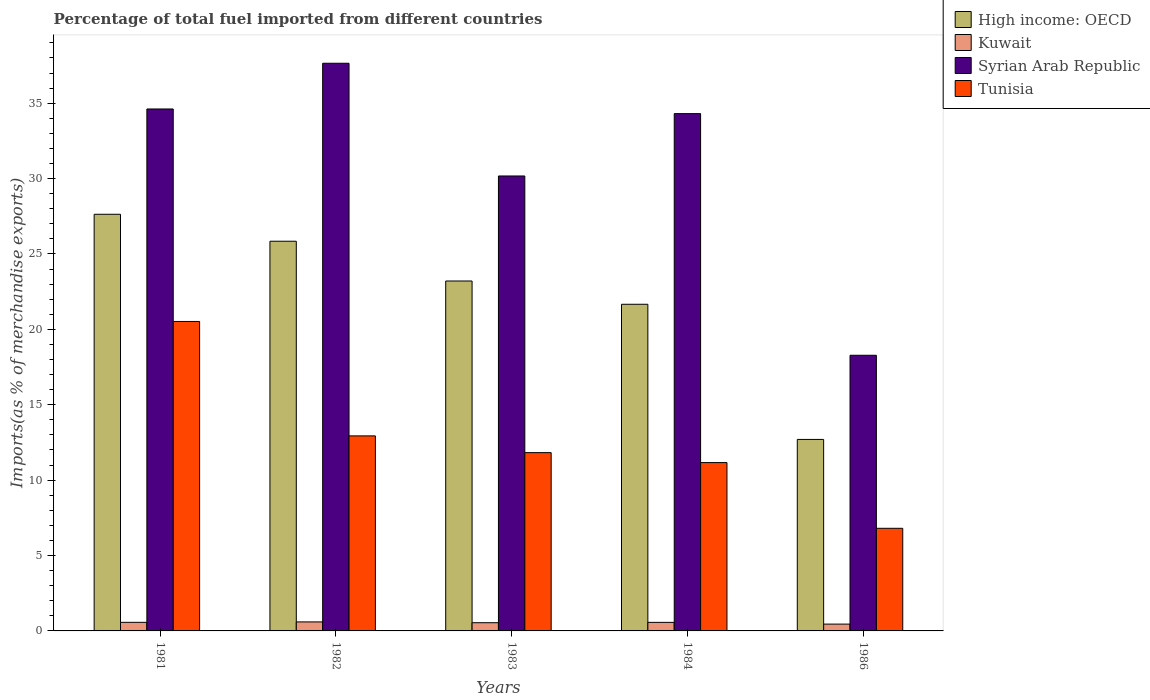How many groups of bars are there?
Make the answer very short. 5. Are the number of bars per tick equal to the number of legend labels?
Keep it short and to the point. Yes. What is the label of the 3rd group of bars from the left?
Make the answer very short. 1983. In how many cases, is the number of bars for a given year not equal to the number of legend labels?
Provide a succinct answer. 0. What is the percentage of imports to different countries in Tunisia in 1982?
Provide a short and direct response. 12.94. Across all years, what is the maximum percentage of imports to different countries in High income: OECD?
Provide a succinct answer. 27.63. Across all years, what is the minimum percentage of imports to different countries in High income: OECD?
Ensure brevity in your answer.  12.7. In which year was the percentage of imports to different countries in Syrian Arab Republic maximum?
Your response must be concise. 1982. What is the total percentage of imports to different countries in Syrian Arab Republic in the graph?
Offer a terse response. 155.03. What is the difference between the percentage of imports to different countries in High income: OECD in 1981 and that in 1983?
Your answer should be very brief. 4.42. What is the difference between the percentage of imports to different countries in High income: OECD in 1981 and the percentage of imports to different countries in Kuwait in 1983?
Your answer should be compact. 27.09. What is the average percentage of imports to different countries in Tunisia per year?
Provide a succinct answer. 12.65. In the year 1982, what is the difference between the percentage of imports to different countries in Syrian Arab Republic and percentage of imports to different countries in High income: OECD?
Your answer should be compact. 11.8. What is the ratio of the percentage of imports to different countries in Syrian Arab Republic in 1981 to that in 1982?
Offer a terse response. 0.92. Is the difference between the percentage of imports to different countries in Syrian Arab Republic in 1981 and 1983 greater than the difference between the percentage of imports to different countries in High income: OECD in 1981 and 1983?
Provide a short and direct response. Yes. What is the difference between the highest and the second highest percentage of imports to different countries in Kuwait?
Your answer should be very brief. 0.03. What is the difference between the highest and the lowest percentage of imports to different countries in High income: OECD?
Your answer should be compact. 14.93. Is it the case that in every year, the sum of the percentage of imports to different countries in High income: OECD and percentage of imports to different countries in Syrian Arab Republic is greater than the sum of percentage of imports to different countries in Kuwait and percentage of imports to different countries in Tunisia?
Your response must be concise. No. What does the 2nd bar from the left in 1984 represents?
Offer a very short reply. Kuwait. What does the 1st bar from the right in 1981 represents?
Give a very brief answer. Tunisia. Is it the case that in every year, the sum of the percentage of imports to different countries in High income: OECD and percentage of imports to different countries in Syrian Arab Republic is greater than the percentage of imports to different countries in Tunisia?
Your answer should be compact. Yes. How many bars are there?
Your answer should be very brief. 20. Does the graph contain grids?
Provide a short and direct response. No. What is the title of the graph?
Your response must be concise. Percentage of total fuel imported from different countries. Does "Burkina Faso" appear as one of the legend labels in the graph?
Your answer should be compact. No. What is the label or title of the X-axis?
Give a very brief answer. Years. What is the label or title of the Y-axis?
Ensure brevity in your answer.  Imports(as % of merchandise exports). What is the Imports(as % of merchandise exports) in High income: OECD in 1981?
Your response must be concise. 27.63. What is the Imports(as % of merchandise exports) of Kuwait in 1981?
Your response must be concise. 0.57. What is the Imports(as % of merchandise exports) in Syrian Arab Republic in 1981?
Give a very brief answer. 34.62. What is the Imports(as % of merchandise exports) of Tunisia in 1981?
Keep it short and to the point. 20.52. What is the Imports(as % of merchandise exports) of High income: OECD in 1982?
Your answer should be very brief. 25.85. What is the Imports(as % of merchandise exports) of Kuwait in 1982?
Your answer should be compact. 0.6. What is the Imports(as % of merchandise exports) in Syrian Arab Republic in 1982?
Provide a succinct answer. 37.65. What is the Imports(as % of merchandise exports) in Tunisia in 1982?
Your answer should be compact. 12.94. What is the Imports(as % of merchandise exports) of High income: OECD in 1983?
Keep it short and to the point. 23.21. What is the Imports(as % of merchandise exports) in Kuwait in 1983?
Provide a succinct answer. 0.54. What is the Imports(as % of merchandise exports) in Syrian Arab Republic in 1983?
Make the answer very short. 30.17. What is the Imports(as % of merchandise exports) in Tunisia in 1983?
Provide a succinct answer. 11.82. What is the Imports(as % of merchandise exports) in High income: OECD in 1984?
Provide a short and direct response. 21.66. What is the Imports(as % of merchandise exports) of Kuwait in 1984?
Your response must be concise. 0.57. What is the Imports(as % of merchandise exports) of Syrian Arab Republic in 1984?
Your response must be concise. 34.31. What is the Imports(as % of merchandise exports) of Tunisia in 1984?
Provide a succinct answer. 11.16. What is the Imports(as % of merchandise exports) of High income: OECD in 1986?
Provide a succinct answer. 12.7. What is the Imports(as % of merchandise exports) in Kuwait in 1986?
Ensure brevity in your answer.  0.45. What is the Imports(as % of merchandise exports) in Syrian Arab Republic in 1986?
Provide a short and direct response. 18.28. What is the Imports(as % of merchandise exports) of Tunisia in 1986?
Make the answer very short. 6.81. Across all years, what is the maximum Imports(as % of merchandise exports) in High income: OECD?
Give a very brief answer. 27.63. Across all years, what is the maximum Imports(as % of merchandise exports) of Kuwait?
Your response must be concise. 0.6. Across all years, what is the maximum Imports(as % of merchandise exports) in Syrian Arab Republic?
Your response must be concise. 37.65. Across all years, what is the maximum Imports(as % of merchandise exports) in Tunisia?
Provide a short and direct response. 20.52. Across all years, what is the minimum Imports(as % of merchandise exports) of High income: OECD?
Provide a succinct answer. 12.7. Across all years, what is the minimum Imports(as % of merchandise exports) of Kuwait?
Provide a succinct answer. 0.45. Across all years, what is the minimum Imports(as % of merchandise exports) of Syrian Arab Republic?
Make the answer very short. 18.28. Across all years, what is the minimum Imports(as % of merchandise exports) in Tunisia?
Your response must be concise. 6.81. What is the total Imports(as % of merchandise exports) of High income: OECD in the graph?
Your answer should be very brief. 111.05. What is the total Imports(as % of merchandise exports) in Kuwait in the graph?
Offer a very short reply. 2.73. What is the total Imports(as % of merchandise exports) of Syrian Arab Republic in the graph?
Keep it short and to the point. 155.03. What is the total Imports(as % of merchandise exports) in Tunisia in the graph?
Ensure brevity in your answer.  63.26. What is the difference between the Imports(as % of merchandise exports) in High income: OECD in 1981 and that in 1982?
Provide a succinct answer. 1.79. What is the difference between the Imports(as % of merchandise exports) in Kuwait in 1981 and that in 1982?
Your response must be concise. -0.03. What is the difference between the Imports(as % of merchandise exports) in Syrian Arab Republic in 1981 and that in 1982?
Give a very brief answer. -3.03. What is the difference between the Imports(as % of merchandise exports) in Tunisia in 1981 and that in 1982?
Your response must be concise. 7.59. What is the difference between the Imports(as % of merchandise exports) in High income: OECD in 1981 and that in 1983?
Your answer should be very brief. 4.42. What is the difference between the Imports(as % of merchandise exports) in Kuwait in 1981 and that in 1983?
Provide a short and direct response. 0.02. What is the difference between the Imports(as % of merchandise exports) of Syrian Arab Republic in 1981 and that in 1983?
Give a very brief answer. 4.44. What is the difference between the Imports(as % of merchandise exports) in Tunisia in 1981 and that in 1983?
Ensure brevity in your answer.  8.7. What is the difference between the Imports(as % of merchandise exports) of High income: OECD in 1981 and that in 1984?
Your answer should be very brief. 5.97. What is the difference between the Imports(as % of merchandise exports) of Kuwait in 1981 and that in 1984?
Provide a short and direct response. 0. What is the difference between the Imports(as % of merchandise exports) in Syrian Arab Republic in 1981 and that in 1984?
Ensure brevity in your answer.  0.31. What is the difference between the Imports(as % of merchandise exports) of Tunisia in 1981 and that in 1984?
Give a very brief answer. 9.36. What is the difference between the Imports(as % of merchandise exports) in High income: OECD in 1981 and that in 1986?
Your answer should be very brief. 14.93. What is the difference between the Imports(as % of merchandise exports) in Kuwait in 1981 and that in 1986?
Give a very brief answer. 0.12. What is the difference between the Imports(as % of merchandise exports) in Syrian Arab Republic in 1981 and that in 1986?
Ensure brevity in your answer.  16.33. What is the difference between the Imports(as % of merchandise exports) in Tunisia in 1981 and that in 1986?
Your answer should be very brief. 13.72. What is the difference between the Imports(as % of merchandise exports) of High income: OECD in 1982 and that in 1983?
Your answer should be compact. 2.64. What is the difference between the Imports(as % of merchandise exports) of Kuwait in 1982 and that in 1983?
Provide a short and direct response. 0.05. What is the difference between the Imports(as % of merchandise exports) in Syrian Arab Republic in 1982 and that in 1983?
Provide a short and direct response. 7.48. What is the difference between the Imports(as % of merchandise exports) of High income: OECD in 1982 and that in 1984?
Your answer should be very brief. 4.18. What is the difference between the Imports(as % of merchandise exports) of Kuwait in 1982 and that in 1984?
Offer a terse response. 0.03. What is the difference between the Imports(as % of merchandise exports) in Syrian Arab Republic in 1982 and that in 1984?
Offer a terse response. 3.34. What is the difference between the Imports(as % of merchandise exports) in Tunisia in 1982 and that in 1984?
Your response must be concise. 1.77. What is the difference between the Imports(as % of merchandise exports) of High income: OECD in 1982 and that in 1986?
Make the answer very short. 13.15. What is the difference between the Imports(as % of merchandise exports) in Kuwait in 1982 and that in 1986?
Ensure brevity in your answer.  0.14. What is the difference between the Imports(as % of merchandise exports) in Syrian Arab Republic in 1982 and that in 1986?
Your answer should be very brief. 19.37. What is the difference between the Imports(as % of merchandise exports) in Tunisia in 1982 and that in 1986?
Ensure brevity in your answer.  6.13. What is the difference between the Imports(as % of merchandise exports) of High income: OECD in 1983 and that in 1984?
Your answer should be compact. 1.54. What is the difference between the Imports(as % of merchandise exports) of Kuwait in 1983 and that in 1984?
Provide a succinct answer. -0.02. What is the difference between the Imports(as % of merchandise exports) in Syrian Arab Republic in 1983 and that in 1984?
Provide a succinct answer. -4.14. What is the difference between the Imports(as % of merchandise exports) of Tunisia in 1983 and that in 1984?
Give a very brief answer. 0.66. What is the difference between the Imports(as % of merchandise exports) in High income: OECD in 1983 and that in 1986?
Offer a terse response. 10.51. What is the difference between the Imports(as % of merchandise exports) of Kuwait in 1983 and that in 1986?
Ensure brevity in your answer.  0.09. What is the difference between the Imports(as % of merchandise exports) of Syrian Arab Republic in 1983 and that in 1986?
Your answer should be compact. 11.89. What is the difference between the Imports(as % of merchandise exports) in Tunisia in 1983 and that in 1986?
Give a very brief answer. 5.02. What is the difference between the Imports(as % of merchandise exports) in High income: OECD in 1984 and that in 1986?
Offer a terse response. 8.96. What is the difference between the Imports(as % of merchandise exports) in Kuwait in 1984 and that in 1986?
Your response must be concise. 0.11. What is the difference between the Imports(as % of merchandise exports) of Syrian Arab Republic in 1984 and that in 1986?
Offer a very short reply. 16.03. What is the difference between the Imports(as % of merchandise exports) of Tunisia in 1984 and that in 1986?
Give a very brief answer. 4.36. What is the difference between the Imports(as % of merchandise exports) in High income: OECD in 1981 and the Imports(as % of merchandise exports) in Kuwait in 1982?
Your answer should be very brief. 27.04. What is the difference between the Imports(as % of merchandise exports) in High income: OECD in 1981 and the Imports(as % of merchandise exports) in Syrian Arab Republic in 1982?
Ensure brevity in your answer.  -10.02. What is the difference between the Imports(as % of merchandise exports) of High income: OECD in 1981 and the Imports(as % of merchandise exports) of Tunisia in 1982?
Make the answer very short. 14.7. What is the difference between the Imports(as % of merchandise exports) of Kuwait in 1981 and the Imports(as % of merchandise exports) of Syrian Arab Republic in 1982?
Provide a succinct answer. -37.08. What is the difference between the Imports(as % of merchandise exports) of Kuwait in 1981 and the Imports(as % of merchandise exports) of Tunisia in 1982?
Your answer should be very brief. -12.37. What is the difference between the Imports(as % of merchandise exports) in Syrian Arab Republic in 1981 and the Imports(as % of merchandise exports) in Tunisia in 1982?
Give a very brief answer. 21.68. What is the difference between the Imports(as % of merchandise exports) of High income: OECD in 1981 and the Imports(as % of merchandise exports) of Kuwait in 1983?
Offer a terse response. 27.09. What is the difference between the Imports(as % of merchandise exports) of High income: OECD in 1981 and the Imports(as % of merchandise exports) of Syrian Arab Republic in 1983?
Make the answer very short. -2.54. What is the difference between the Imports(as % of merchandise exports) in High income: OECD in 1981 and the Imports(as % of merchandise exports) in Tunisia in 1983?
Keep it short and to the point. 15.81. What is the difference between the Imports(as % of merchandise exports) of Kuwait in 1981 and the Imports(as % of merchandise exports) of Syrian Arab Republic in 1983?
Ensure brevity in your answer.  -29.6. What is the difference between the Imports(as % of merchandise exports) of Kuwait in 1981 and the Imports(as % of merchandise exports) of Tunisia in 1983?
Offer a very short reply. -11.26. What is the difference between the Imports(as % of merchandise exports) of Syrian Arab Republic in 1981 and the Imports(as % of merchandise exports) of Tunisia in 1983?
Your answer should be very brief. 22.79. What is the difference between the Imports(as % of merchandise exports) of High income: OECD in 1981 and the Imports(as % of merchandise exports) of Kuwait in 1984?
Provide a succinct answer. 27.07. What is the difference between the Imports(as % of merchandise exports) in High income: OECD in 1981 and the Imports(as % of merchandise exports) in Syrian Arab Republic in 1984?
Your response must be concise. -6.68. What is the difference between the Imports(as % of merchandise exports) of High income: OECD in 1981 and the Imports(as % of merchandise exports) of Tunisia in 1984?
Offer a terse response. 16.47. What is the difference between the Imports(as % of merchandise exports) of Kuwait in 1981 and the Imports(as % of merchandise exports) of Syrian Arab Republic in 1984?
Keep it short and to the point. -33.74. What is the difference between the Imports(as % of merchandise exports) in Kuwait in 1981 and the Imports(as % of merchandise exports) in Tunisia in 1984?
Your answer should be very brief. -10.6. What is the difference between the Imports(as % of merchandise exports) in Syrian Arab Republic in 1981 and the Imports(as % of merchandise exports) in Tunisia in 1984?
Your answer should be compact. 23.45. What is the difference between the Imports(as % of merchandise exports) of High income: OECD in 1981 and the Imports(as % of merchandise exports) of Kuwait in 1986?
Provide a short and direct response. 27.18. What is the difference between the Imports(as % of merchandise exports) of High income: OECD in 1981 and the Imports(as % of merchandise exports) of Syrian Arab Republic in 1986?
Your answer should be very brief. 9.35. What is the difference between the Imports(as % of merchandise exports) in High income: OECD in 1981 and the Imports(as % of merchandise exports) in Tunisia in 1986?
Your answer should be compact. 20.83. What is the difference between the Imports(as % of merchandise exports) in Kuwait in 1981 and the Imports(as % of merchandise exports) in Syrian Arab Republic in 1986?
Offer a terse response. -17.71. What is the difference between the Imports(as % of merchandise exports) of Kuwait in 1981 and the Imports(as % of merchandise exports) of Tunisia in 1986?
Make the answer very short. -6.24. What is the difference between the Imports(as % of merchandise exports) in Syrian Arab Republic in 1981 and the Imports(as % of merchandise exports) in Tunisia in 1986?
Offer a very short reply. 27.81. What is the difference between the Imports(as % of merchandise exports) of High income: OECD in 1982 and the Imports(as % of merchandise exports) of Kuwait in 1983?
Provide a succinct answer. 25.3. What is the difference between the Imports(as % of merchandise exports) of High income: OECD in 1982 and the Imports(as % of merchandise exports) of Syrian Arab Republic in 1983?
Provide a short and direct response. -4.33. What is the difference between the Imports(as % of merchandise exports) of High income: OECD in 1982 and the Imports(as % of merchandise exports) of Tunisia in 1983?
Your answer should be compact. 14.02. What is the difference between the Imports(as % of merchandise exports) of Kuwait in 1982 and the Imports(as % of merchandise exports) of Syrian Arab Republic in 1983?
Make the answer very short. -29.58. What is the difference between the Imports(as % of merchandise exports) of Kuwait in 1982 and the Imports(as % of merchandise exports) of Tunisia in 1983?
Provide a short and direct response. -11.23. What is the difference between the Imports(as % of merchandise exports) in Syrian Arab Republic in 1982 and the Imports(as % of merchandise exports) in Tunisia in 1983?
Your response must be concise. 25.82. What is the difference between the Imports(as % of merchandise exports) of High income: OECD in 1982 and the Imports(as % of merchandise exports) of Kuwait in 1984?
Ensure brevity in your answer.  25.28. What is the difference between the Imports(as % of merchandise exports) of High income: OECD in 1982 and the Imports(as % of merchandise exports) of Syrian Arab Republic in 1984?
Your answer should be compact. -8.46. What is the difference between the Imports(as % of merchandise exports) of High income: OECD in 1982 and the Imports(as % of merchandise exports) of Tunisia in 1984?
Offer a very short reply. 14.68. What is the difference between the Imports(as % of merchandise exports) in Kuwait in 1982 and the Imports(as % of merchandise exports) in Syrian Arab Republic in 1984?
Your answer should be compact. -33.71. What is the difference between the Imports(as % of merchandise exports) of Kuwait in 1982 and the Imports(as % of merchandise exports) of Tunisia in 1984?
Offer a terse response. -10.57. What is the difference between the Imports(as % of merchandise exports) in Syrian Arab Republic in 1982 and the Imports(as % of merchandise exports) in Tunisia in 1984?
Keep it short and to the point. 26.48. What is the difference between the Imports(as % of merchandise exports) in High income: OECD in 1982 and the Imports(as % of merchandise exports) in Kuwait in 1986?
Your answer should be compact. 25.39. What is the difference between the Imports(as % of merchandise exports) in High income: OECD in 1982 and the Imports(as % of merchandise exports) in Syrian Arab Republic in 1986?
Keep it short and to the point. 7.56. What is the difference between the Imports(as % of merchandise exports) in High income: OECD in 1982 and the Imports(as % of merchandise exports) in Tunisia in 1986?
Your response must be concise. 19.04. What is the difference between the Imports(as % of merchandise exports) in Kuwait in 1982 and the Imports(as % of merchandise exports) in Syrian Arab Republic in 1986?
Provide a short and direct response. -17.69. What is the difference between the Imports(as % of merchandise exports) in Kuwait in 1982 and the Imports(as % of merchandise exports) in Tunisia in 1986?
Make the answer very short. -6.21. What is the difference between the Imports(as % of merchandise exports) of Syrian Arab Republic in 1982 and the Imports(as % of merchandise exports) of Tunisia in 1986?
Offer a terse response. 30.84. What is the difference between the Imports(as % of merchandise exports) in High income: OECD in 1983 and the Imports(as % of merchandise exports) in Kuwait in 1984?
Make the answer very short. 22.64. What is the difference between the Imports(as % of merchandise exports) in High income: OECD in 1983 and the Imports(as % of merchandise exports) in Syrian Arab Republic in 1984?
Offer a very short reply. -11.1. What is the difference between the Imports(as % of merchandise exports) in High income: OECD in 1983 and the Imports(as % of merchandise exports) in Tunisia in 1984?
Give a very brief answer. 12.04. What is the difference between the Imports(as % of merchandise exports) of Kuwait in 1983 and the Imports(as % of merchandise exports) of Syrian Arab Republic in 1984?
Ensure brevity in your answer.  -33.76. What is the difference between the Imports(as % of merchandise exports) of Kuwait in 1983 and the Imports(as % of merchandise exports) of Tunisia in 1984?
Offer a terse response. -10.62. What is the difference between the Imports(as % of merchandise exports) of Syrian Arab Republic in 1983 and the Imports(as % of merchandise exports) of Tunisia in 1984?
Provide a short and direct response. 19.01. What is the difference between the Imports(as % of merchandise exports) in High income: OECD in 1983 and the Imports(as % of merchandise exports) in Kuwait in 1986?
Provide a short and direct response. 22.76. What is the difference between the Imports(as % of merchandise exports) in High income: OECD in 1983 and the Imports(as % of merchandise exports) in Syrian Arab Republic in 1986?
Your response must be concise. 4.93. What is the difference between the Imports(as % of merchandise exports) in High income: OECD in 1983 and the Imports(as % of merchandise exports) in Tunisia in 1986?
Offer a terse response. 16.4. What is the difference between the Imports(as % of merchandise exports) in Kuwait in 1983 and the Imports(as % of merchandise exports) in Syrian Arab Republic in 1986?
Your answer should be very brief. -17.74. What is the difference between the Imports(as % of merchandise exports) of Kuwait in 1983 and the Imports(as % of merchandise exports) of Tunisia in 1986?
Provide a succinct answer. -6.26. What is the difference between the Imports(as % of merchandise exports) in Syrian Arab Republic in 1983 and the Imports(as % of merchandise exports) in Tunisia in 1986?
Give a very brief answer. 23.37. What is the difference between the Imports(as % of merchandise exports) of High income: OECD in 1984 and the Imports(as % of merchandise exports) of Kuwait in 1986?
Ensure brevity in your answer.  21.21. What is the difference between the Imports(as % of merchandise exports) of High income: OECD in 1984 and the Imports(as % of merchandise exports) of Syrian Arab Republic in 1986?
Offer a very short reply. 3.38. What is the difference between the Imports(as % of merchandise exports) of High income: OECD in 1984 and the Imports(as % of merchandise exports) of Tunisia in 1986?
Your answer should be compact. 14.86. What is the difference between the Imports(as % of merchandise exports) of Kuwait in 1984 and the Imports(as % of merchandise exports) of Syrian Arab Republic in 1986?
Provide a succinct answer. -17.72. What is the difference between the Imports(as % of merchandise exports) of Kuwait in 1984 and the Imports(as % of merchandise exports) of Tunisia in 1986?
Provide a succinct answer. -6.24. What is the difference between the Imports(as % of merchandise exports) in Syrian Arab Republic in 1984 and the Imports(as % of merchandise exports) in Tunisia in 1986?
Your answer should be very brief. 27.5. What is the average Imports(as % of merchandise exports) in High income: OECD per year?
Give a very brief answer. 22.21. What is the average Imports(as % of merchandise exports) of Kuwait per year?
Keep it short and to the point. 0.55. What is the average Imports(as % of merchandise exports) in Syrian Arab Republic per year?
Make the answer very short. 31.01. What is the average Imports(as % of merchandise exports) in Tunisia per year?
Make the answer very short. 12.65. In the year 1981, what is the difference between the Imports(as % of merchandise exports) of High income: OECD and Imports(as % of merchandise exports) of Kuwait?
Your answer should be very brief. 27.06. In the year 1981, what is the difference between the Imports(as % of merchandise exports) of High income: OECD and Imports(as % of merchandise exports) of Syrian Arab Republic?
Your answer should be compact. -6.98. In the year 1981, what is the difference between the Imports(as % of merchandise exports) of High income: OECD and Imports(as % of merchandise exports) of Tunisia?
Ensure brevity in your answer.  7.11. In the year 1981, what is the difference between the Imports(as % of merchandise exports) of Kuwait and Imports(as % of merchandise exports) of Syrian Arab Republic?
Your response must be concise. -34.05. In the year 1981, what is the difference between the Imports(as % of merchandise exports) of Kuwait and Imports(as % of merchandise exports) of Tunisia?
Give a very brief answer. -19.95. In the year 1981, what is the difference between the Imports(as % of merchandise exports) in Syrian Arab Republic and Imports(as % of merchandise exports) in Tunisia?
Make the answer very short. 14.09. In the year 1982, what is the difference between the Imports(as % of merchandise exports) of High income: OECD and Imports(as % of merchandise exports) of Kuwait?
Your answer should be very brief. 25.25. In the year 1982, what is the difference between the Imports(as % of merchandise exports) of High income: OECD and Imports(as % of merchandise exports) of Syrian Arab Republic?
Give a very brief answer. -11.8. In the year 1982, what is the difference between the Imports(as % of merchandise exports) of High income: OECD and Imports(as % of merchandise exports) of Tunisia?
Your answer should be compact. 12.91. In the year 1982, what is the difference between the Imports(as % of merchandise exports) of Kuwait and Imports(as % of merchandise exports) of Syrian Arab Republic?
Ensure brevity in your answer.  -37.05. In the year 1982, what is the difference between the Imports(as % of merchandise exports) in Kuwait and Imports(as % of merchandise exports) in Tunisia?
Make the answer very short. -12.34. In the year 1982, what is the difference between the Imports(as % of merchandise exports) of Syrian Arab Republic and Imports(as % of merchandise exports) of Tunisia?
Keep it short and to the point. 24.71. In the year 1983, what is the difference between the Imports(as % of merchandise exports) of High income: OECD and Imports(as % of merchandise exports) of Kuwait?
Make the answer very short. 22.66. In the year 1983, what is the difference between the Imports(as % of merchandise exports) of High income: OECD and Imports(as % of merchandise exports) of Syrian Arab Republic?
Give a very brief answer. -6.97. In the year 1983, what is the difference between the Imports(as % of merchandise exports) in High income: OECD and Imports(as % of merchandise exports) in Tunisia?
Make the answer very short. 11.38. In the year 1983, what is the difference between the Imports(as % of merchandise exports) in Kuwait and Imports(as % of merchandise exports) in Syrian Arab Republic?
Provide a succinct answer. -29.63. In the year 1983, what is the difference between the Imports(as % of merchandise exports) in Kuwait and Imports(as % of merchandise exports) in Tunisia?
Your response must be concise. -11.28. In the year 1983, what is the difference between the Imports(as % of merchandise exports) of Syrian Arab Republic and Imports(as % of merchandise exports) of Tunisia?
Make the answer very short. 18.35. In the year 1984, what is the difference between the Imports(as % of merchandise exports) of High income: OECD and Imports(as % of merchandise exports) of Kuwait?
Ensure brevity in your answer.  21.1. In the year 1984, what is the difference between the Imports(as % of merchandise exports) of High income: OECD and Imports(as % of merchandise exports) of Syrian Arab Republic?
Offer a terse response. -12.64. In the year 1984, what is the difference between the Imports(as % of merchandise exports) in High income: OECD and Imports(as % of merchandise exports) in Tunisia?
Your answer should be compact. 10.5. In the year 1984, what is the difference between the Imports(as % of merchandise exports) of Kuwait and Imports(as % of merchandise exports) of Syrian Arab Republic?
Provide a short and direct response. -33.74. In the year 1984, what is the difference between the Imports(as % of merchandise exports) of Kuwait and Imports(as % of merchandise exports) of Tunisia?
Provide a short and direct response. -10.6. In the year 1984, what is the difference between the Imports(as % of merchandise exports) in Syrian Arab Republic and Imports(as % of merchandise exports) in Tunisia?
Your response must be concise. 23.14. In the year 1986, what is the difference between the Imports(as % of merchandise exports) in High income: OECD and Imports(as % of merchandise exports) in Kuwait?
Offer a very short reply. 12.25. In the year 1986, what is the difference between the Imports(as % of merchandise exports) of High income: OECD and Imports(as % of merchandise exports) of Syrian Arab Republic?
Your response must be concise. -5.58. In the year 1986, what is the difference between the Imports(as % of merchandise exports) of High income: OECD and Imports(as % of merchandise exports) of Tunisia?
Offer a very short reply. 5.89. In the year 1986, what is the difference between the Imports(as % of merchandise exports) in Kuwait and Imports(as % of merchandise exports) in Syrian Arab Republic?
Make the answer very short. -17.83. In the year 1986, what is the difference between the Imports(as % of merchandise exports) in Kuwait and Imports(as % of merchandise exports) in Tunisia?
Ensure brevity in your answer.  -6.35. In the year 1986, what is the difference between the Imports(as % of merchandise exports) of Syrian Arab Republic and Imports(as % of merchandise exports) of Tunisia?
Offer a very short reply. 11.48. What is the ratio of the Imports(as % of merchandise exports) of High income: OECD in 1981 to that in 1982?
Give a very brief answer. 1.07. What is the ratio of the Imports(as % of merchandise exports) in Kuwait in 1981 to that in 1982?
Give a very brief answer. 0.95. What is the ratio of the Imports(as % of merchandise exports) in Syrian Arab Republic in 1981 to that in 1982?
Provide a succinct answer. 0.92. What is the ratio of the Imports(as % of merchandise exports) in Tunisia in 1981 to that in 1982?
Your response must be concise. 1.59. What is the ratio of the Imports(as % of merchandise exports) of High income: OECD in 1981 to that in 1983?
Your response must be concise. 1.19. What is the ratio of the Imports(as % of merchandise exports) in Kuwait in 1981 to that in 1983?
Your response must be concise. 1.04. What is the ratio of the Imports(as % of merchandise exports) in Syrian Arab Republic in 1981 to that in 1983?
Give a very brief answer. 1.15. What is the ratio of the Imports(as % of merchandise exports) of Tunisia in 1981 to that in 1983?
Your answer should be compact. 1.74. What is the ratio of the Imports(as % of merchandise exports) of High income: OECD in 1981 to that in 1984?
Offer a terse response. 1.28. What is the ratio of the Imports(as % of merchandise exports) of Kuwait in 1981 to that in 1984?
Provide a succinct answer. 1. What is the ratio of the Imports(as % of merchandise exports) of Syrian Arab Republic in 1981 to that in 1984?
Provide a short and direct response. 1.01. What is the ratio of the Imports(as % of merchandise exports) in Tunisia in 1981 to that in 1984?
Ensure brevity in your answer.  1.84. What is the ratio of the Imports(as % of merchandise exports) of High income: OECD in 1981 to that in 1986?
Ensure brevity in your answer.  2.18. What is the ratio of the Imports(as % of merchandise exports) in Kuwait in 1981 to that in 1986?
Offer a very short reply. 1.26. What is the ratio of the Imports(as % of merchandise exports) in Syrian Arab Republic in 1981 to that in 1986?
Your response must be concise. 1.89. What is the ratio of the Imports(as % of merchandise exports) of Tunisia in 1981 to that in 1986?
Make the answer very short. 3.02. What is the ratio of the Imports(as % of merchandise exports) in High income: OECD in 1982 to that in 1983?
Ensure brevity in your answer.  1.11. What is the ratio of the Imports(as % of merchandise exports) of Kuwait in 1982 to that in 1983?
Provide a succinct answer. 1.1. What is the ratio of the Imports(as % of merchandise exports) of Syrian Arab Republic in 1982 to that in 1983?
Provide a short and direct response. 1.25. What is the ratio of the Imports(as % of merchandise exports) in Tunisia in 1982 to that in 1983?
Your response must be concise. 1.09. What is the ratio of the Imports(as % of merchandise exports) of High income: OECD in 1982 to that in 1984?
Offer a very short reply. 1.19. What is the ratio of the Imports(as % of merchandise exports) in Kuwait in 1982 to that in 1984?
Offer a very short reply. 1.05. What is the ratio of the Imports(as % of merchandise exports) of Syrian Arab Republic in 1982 to that in 1984?
Provide a short and direct response. 1.1. What is the ratio of the Imports(as % of merchandise exports) in Tunisia in 1982 to that in 1984?
Offer a terse response. 1.16. What is the ratio of the Imports(as % of merchandise exports) of High income: OECD in 1982 to that in 1986?
Your answer should be very brief. 2.04. What is the ratio of the Imports(as % of merchandise exports) in Kuwait in 1982 to that in 1986?
Offer a terse response. 1.32. What is the ratio of the Imports(as % of merchandise exports) in Syrian Arab Republic in 1982 to that in 1986?
Your response must be concise. 2.06. What is the ratio of the Imports(as % of merchandise exports) in Tunisia in 1982 to that in 1986?
Ensure brevity in your answer.  1.9. What is the ratio of the Imports(as % of merchandise exports) in High income: OECD in 1983 to that in 1984?
Make the answer very short. 1.07. What is the ratio of the Imports(as % of merchandise exports) of Kuwait in 1983 to that in 1984?
Give a very brief answer. 0.96. What is the ratio of the Imports(as % of merchandise exports) in Syrian Arab Republic in 1983 to that in 1984?
Your answer should be compact. 0.88. What is the ratio of the Imports(as % of merchandise exports) of Tunisia in 1983 to that in 1984?
Offer a very short reply. 1.06. What is the ratio of the Imports(as % of merchandise exports) of High income: OECD in 1983 to that in 1986?
Provide a succinct answer. 1.83. What is the ratio of the Imports(as % of merchandise exports) in Kuwait in 1983 to that in 1986?
Make the answer very short. 1.2. What is the ratio of the Imports(as % of merchandise exports) in Syrian Arab Republic in 1983 to that in 1986?
Provide a short and direct response. 1.65. What is the ratio of the Imports(as % of merchandise exports) of Tunisia in 1983 to that in 1986?
Your answer should be very brief. 1.74. What is the ratio of the Imports(as % of merchandise exports) in High income: OECD in 1984 to that in 1986?
Your answer should be compact. 1.71. What is the ratio of the Imports(as % of merchandise exports) of Kuwait in 1984 to that in 1986?
Offer a terse response. 1.25. What is the ratio of the Imports(as % of merchandise exports) of Syrian Arab Republic in 1984 to that in 1986?
Keep it short and to the point. 1.88. What is the ratio of the Imports(as % of merchandise exports) in Tunisia in 1984 to that in 1986?
Offer a terse response. 1.64. What is the difference between the highest and the second highest Imports(as % of merchandise exports) of High income: OECD?
Your response must be concise. 1.79. What is the difference between the highest and the second highest Imports(as % of merchandise exports) in Kuwait?
Make the answer very short. 0.03. What is the difference between the highest and the second highest Imports(as % of merchandise exports) of Syrian Arab Republic?
Offer a very short reply. 3.03. What is the difference between the highest and the second highest Imports(as % of merchandise exports) in Tunisia?
Ensure brevity in your answer.  7.59. What is the difference between the highest and the lowest Imports(as % of merchandise exports) in High income: OECD?
Your response must be concise. 14.93. What is the difference between the highest and the lowest Imports(as % of merchandise exports) in Kuwait?
Provide a succinct answer. 0.14. What is the difference between the highest and the lowest Imports(as % of merchandise exports) in Syrian Arab Republic?
Ensure brevity in your answer.  19.37. What is the difference between the highest and the lowest Imports(as % of merchandise exports) of Tunisia?
Your response must be concise. 13.72. 